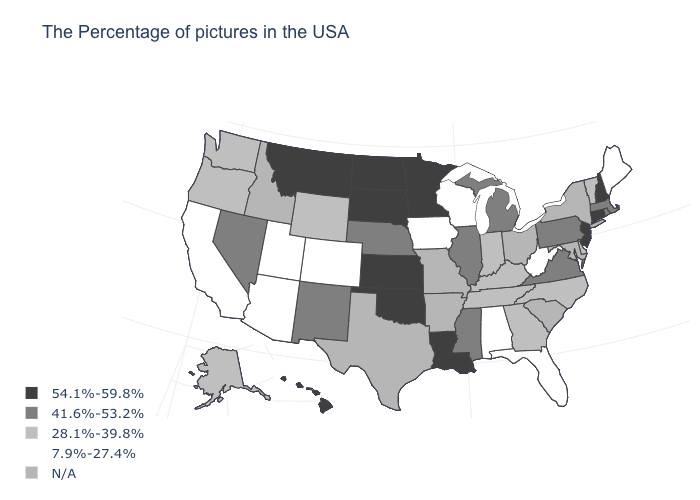Name the states that have a value in the range 7.9%-27.4%?
Short answer required. Maine, West Virginia, Florida, Alabama, Wisconsin, Iowa, Colorado, Utah, Arizona, California. Is the legend a continuous bar?
Quick response, please. No. Which states have the lowest value in the Northeast?
Be succinct. Maine. Does Arizona have the lowest value in the West?
Concise answer only. Yes. What is the value of New Hampshire?
Concise answer only. 54.1%-59.8%. Name the states that have a value in the range 7.9%-27.4%?
Concise answer only. Maine, West Virginia, Florida, Alabama, Wisconsin, Iowa, Colorado, Utah, Arizona, California. What is the value of Oregon?
Be succinct. 28.1%-39.8%. Does the first symbol in the legend represent the smallest category?
Answer briefly. No. What is the value of South Dakota?
Write a very short answer. 54.1%-59.8%. Is the legend a continuous bar?
Concise answer only. No. Name the states that have a value in the range 28.1%-39.8%?
Keep it brief. Vermont, Delaware, North Carolina, Georgia, Kentucky, Indiana, Tennessee, Wyoming, Washington, Oregon, Alaska. Among the states that border Maryland , does West Virginia have the highest value?
Keep it brief. No. What is the highest value in states that border Arkansas?
Be succinct. 54.1%-59.8%. 